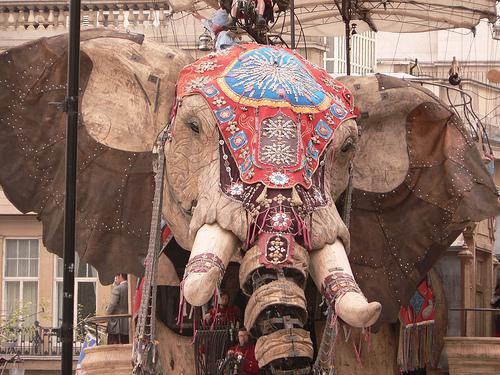Question: what are the tusks made of?
Choices:
A. Chiton.
B. Calcium.
C. Bones.
D. Ivory.
Answer with the letter. Answer: D Question: who has large ears?
Choices:
A. The beagle.
B. The elephant.
C. The Basset Hound.
D. My grandpa.
Answer with the letter. Answer: B Question: where is the building?
Choices:
A. On 5th St.
B. Behind the elephant.
C. Downtown.
D. To the left of the harbour.
Answer with the letter. Answer: B Question: when is the photo taken?
Choices:
A. At night.
B. During the day.
C. In the rain.
D. In the snow.
Answer with the letter. Answer: B 